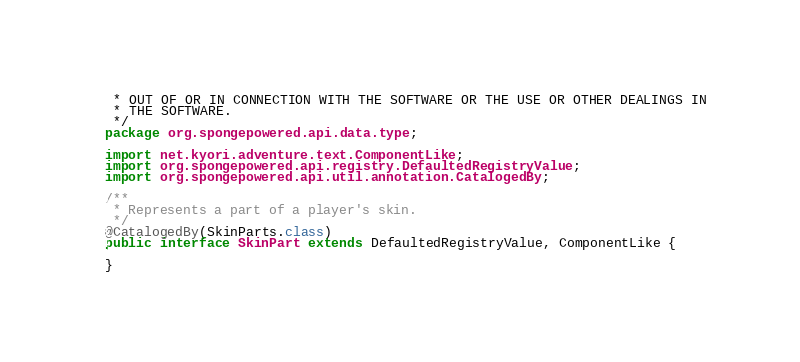Convert code to text. <code><loc_0><loc_0><loc_500><loc_500><_Java_> * OUT OF OR IN CONNECTION WITH THE SOFTWARE OR THE USE OR OTHER DEALINGS IN
 * THE SOFTWARE.
 */
package org.spongepowered.api.data.type;

import net.kyori.adventure.text.ComponentLike;
import org.spongepowered.api.registry.DefaultedRegistryValue;
import org.spongepowered.api.util.annotation.CatalogedBy;

/**
 * Represents a part of a player's skin.
 */
@CatalogedBy(SkinParts.class)
public interface SkinPart extends DefaultedRegistryValue, ComponentLike {

}
</code> 